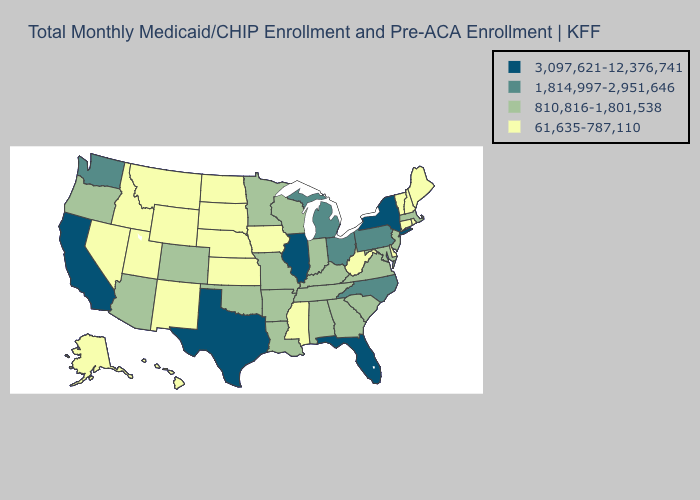Name the states that have a value in the range 1,814,997-2,951,646?
Be succinct. Michigan, North Carolina, Ohio, Pennsylvania, Washington. Which states have the highest value in the USA?
Answer briefly. California, Florida, Illinois, New York, Texas. Does South Carolina have the same value as Virginia?
Be succinct. Yes. Does Nebraska have the lowest value in the USA?
Write a very short answer. Yes. Does Georgia have the lowest value in the South?
Short answer required. No. Which states have the lowest value in the Northeast?
Keep it brief. Connecticut, Maine, New Hampshire, Rhode Island, Vermont. Which states hav the highest value in the Northeast?
Short answer required. New York. Does Maryland have the highest value in the South?
Short answer required. No. What is the value of Alaska?
Keep it brief. 61,635-787,110. What is the value of Mississippi?
Give a very brief answer. 61,635-787,110. What is the highest value in the Northeast ?
Answer briefly. 3,097,621-12,376,741. Does Wisconsin have the lowest value in the MidWest?
Be succinct. No. Which states have the highest value in the USA?
Quick response, please. California, Florida, Illinois, New York, Texas. Does Illinois have the highest value in the USA?
Give a very brief answer. Yes. Name the states that have a value in the range 1,814,997-2,951,646?
Short answer required. Michigan, North Carolina, Ohio, Pennsylvania, Washington. 